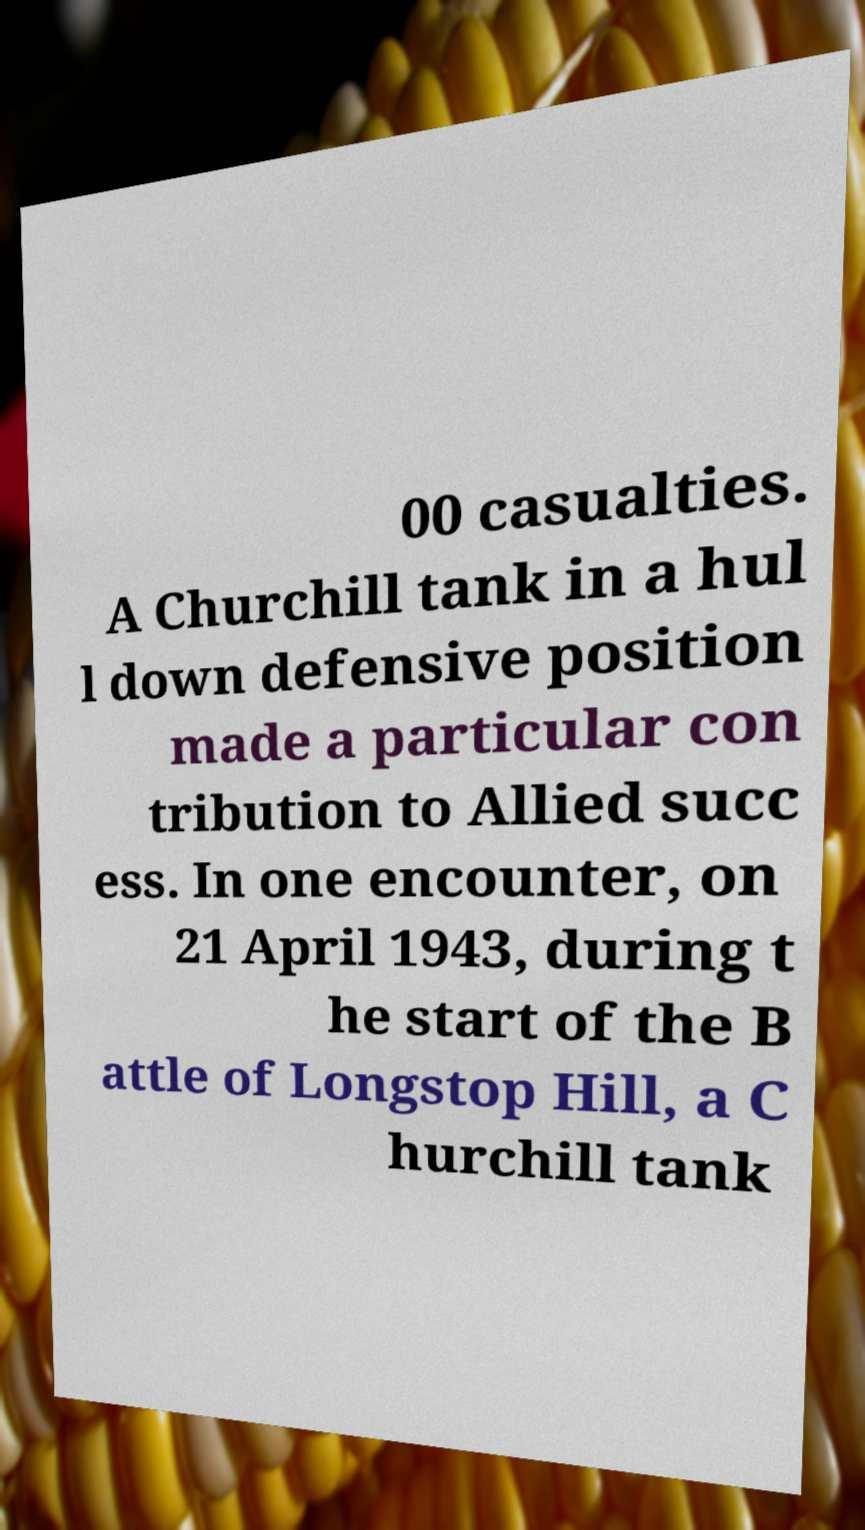Can you accurately transcribe the text from the provided image for me? 00 casualties. A Churchill tank in a hul l down defensive position made a particular con tribution to Allied succ ess. In one encounter, on 21 April 1943, during t he start of the B attle of Longstop Hill, a C hurchill tank 